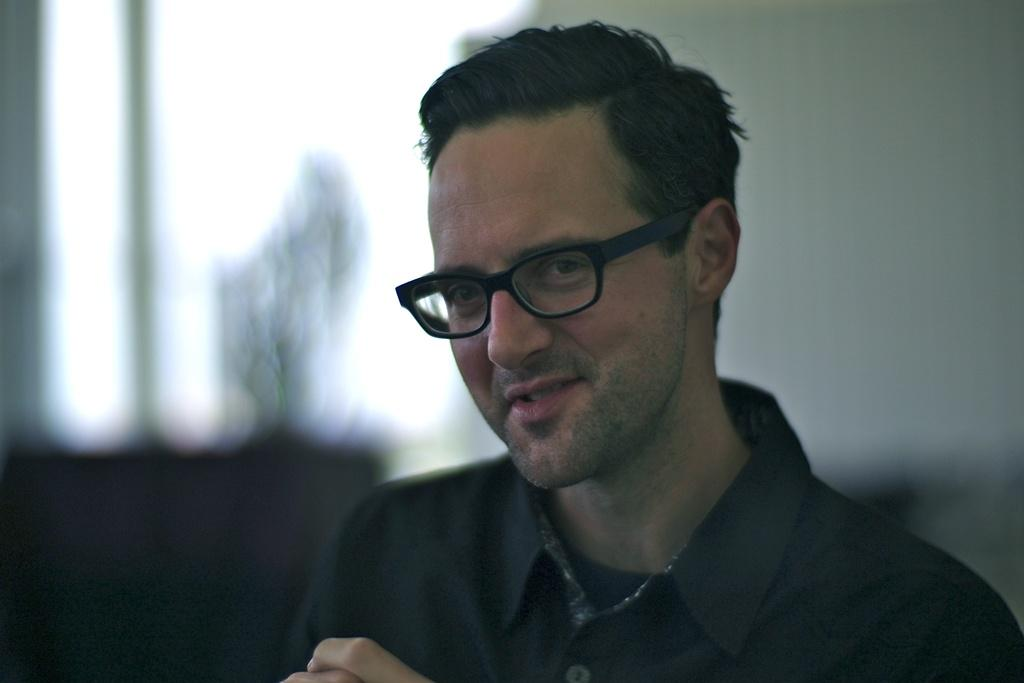What is the main subject of the image? There is a man in the image. What is the man wearing on his upper body? The man is wearing a shirt. Are there any accessories visible on the man in the image? Yes, the man is wearing glasses. What type of reward does the man receive after the event? There is no mention of a reward or an event in the image, so it is not possible to answer that question. 